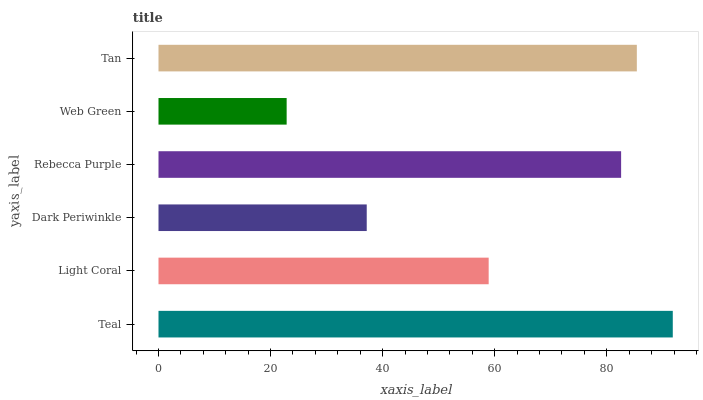Is Web Green the minimum?
Answer yes or no. Yes. Is Teal the maximum?
Answer yes or no. Yes. Is Light Coral the minimum?
Answer yes or no. No. Is Light Coral the maximum?
Answer yes or no. No. Is Teal greater than Light Coral?
Answer yes or no. Yes. Is Light Coral less than Teal?
Answer yes or no. Yes. Is Light Coral greater than Teal?
Answer yes or no. No. Is Teal less than Light Coral?
Answer yes or no. No. Is Rebecca Purple the high median?
Answer yes or no. Yes. Is Light Coral the low median?
Answer yes or no. Yes. Is Web Green the high median?
Answer yes or no. No. Is Teal the low median?
Answer yes or no. No. 